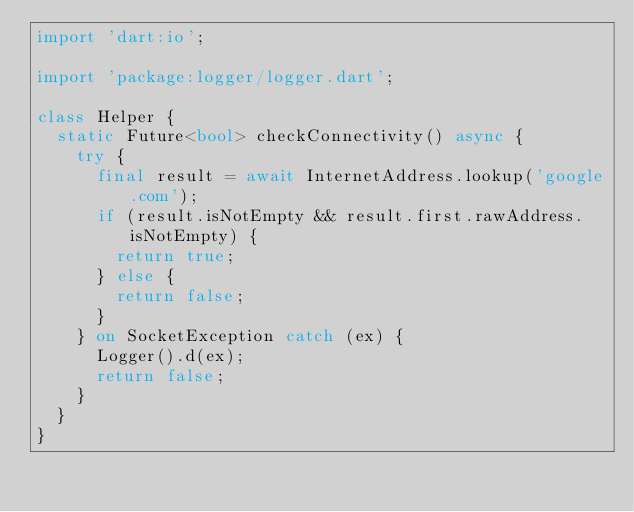<code> <loc_0><loc_0><loc_500><loc_500><_Dart_>import 'dart:io';

import 'package:logger/logger.dart';

class Helper {
  static Future<bool> checkConnectivity() async {
    try {
      final result = await InternetAddress.lookup('google.com');
      if (result.isNotEmpty && result.first.rawAddress.isNotEmpty) {
        return true;
      } else {
        return false;
      }
    } on SocketException catch (ex) {
      Logger().d(ex);
      return false;
    }
  }
}
</code> 